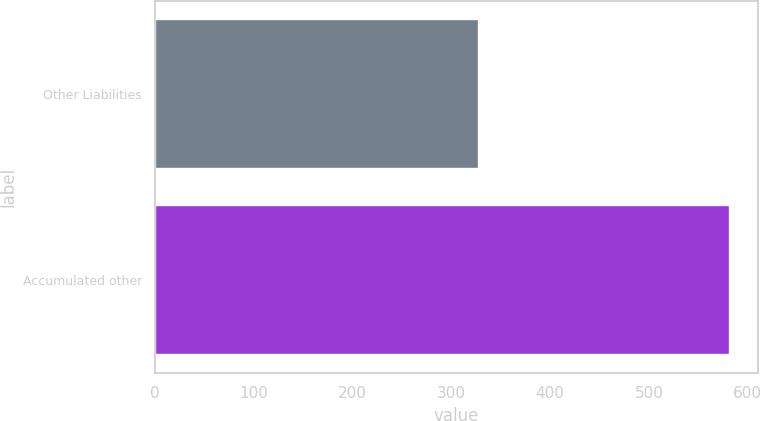Convert chart. <chart><loc_0><loc_0><loc_500><loc_500><bar_chart><fcel>Other Liabilities<fcel>Accumulated other<nl><fcel>327<fcel>581<nl></chart> 